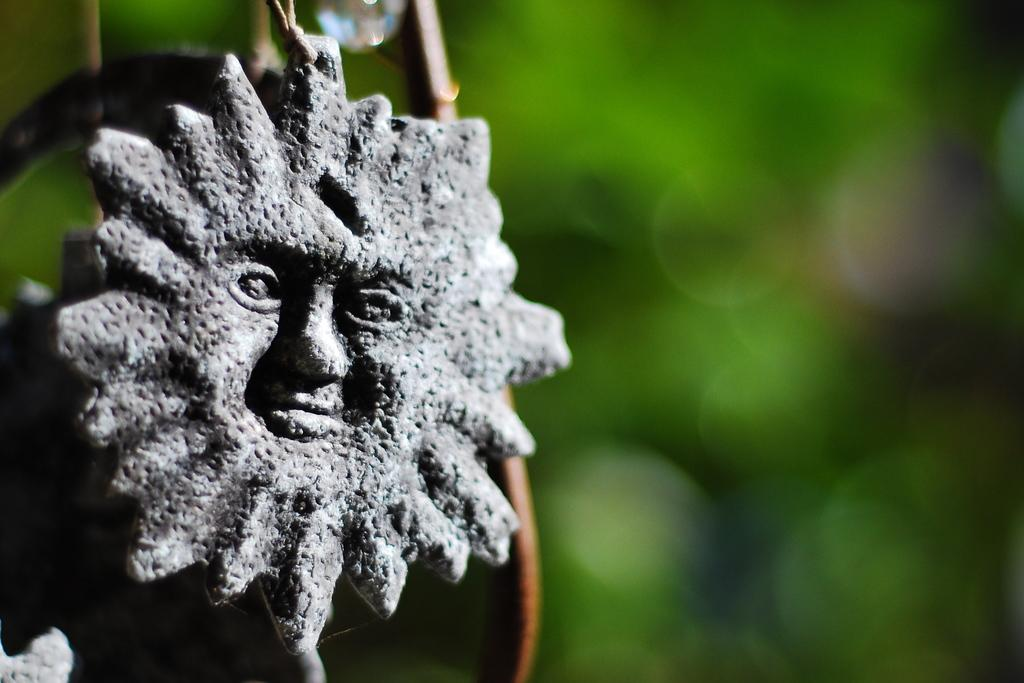What object is the main focus of the image? There is a locket in the image. What material is the locket made of? The locket is made of stone. What shape does the locket have? The locket is in the shape of a human face. How would you describe the background of the image? The background of the image is blurry and has a green color. Is there any blood visible on the locket in the image? No, there is no blood visible on the locket in the image. What type of soap is used to clean the locket in the image? There is no soap present in the image, as it focuses on the locket and its background. 